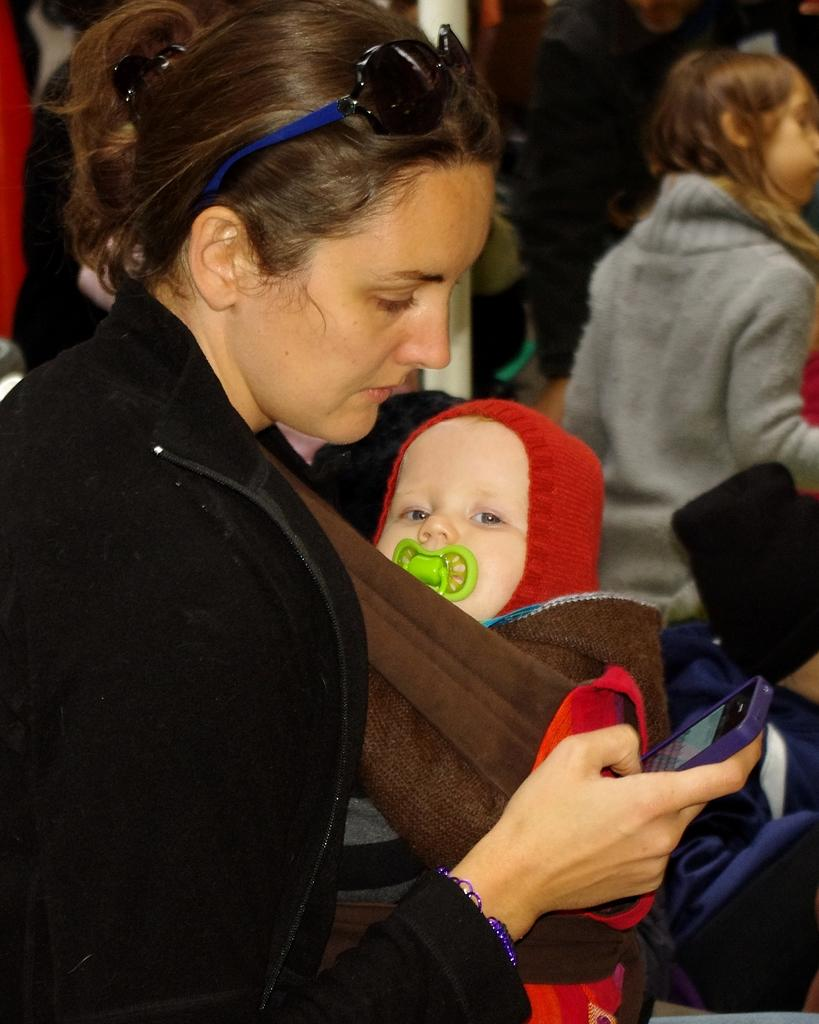How many people are in the image? There are people in the image. What is one person doing in the image? One person is holding a baby. What else is the person holding besides the baby? The person holding the baby is also holding a mobile. What color is the jacket worn by the person holding the baby? The person holding the baby is wearing a black color jacket. What is the rate of the cannon being fired in the image? There is no cannon present in the image, so it is not possible to determine the rate at which it would be fired. 